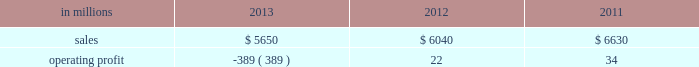Input costs for board and resin are expected to be flat and operating costs are expected to decrease .
European consumer packaging net sales in 2013 were $ 380 million compared with $ 380 million in 2012 and $ 375 million in 2011 .
Operating profits in 2013 were $ 100 million compared with $ 99 million in 2012 and $ 93 million in 2011 .
Sales volumes in 2013 decreased from 2012 in both the european and russian markets .
Average sales price realizations were significantly higher in the russian market , but were lower in europe .
Input costs were flat year-over-year .
Planned maintenance downtime costs were higher in 2013 than in 2012 .
Looking forward to the first quarter of 2014 , sales volumes compared with the fourth quarter of 2013 are expected to be about flat .
Average sales price realizations are expected to be higher in both russia and europe .
Input costs are expected to increase for wood and energy , but decrease for purchased pulp .
There are no maintenance outages scheduled for the first quarter , however the kwidzyn mill will have additional costs associated with the rebuild of a coated board machine .
Asian consumer packaging net sales were $ 1.1 billion in 2013 compared with $ 830 million in 2012 and $ 855 million in 2011 .
Operating profits in 2013 were a loss of $ 2 million compared with gains of $ 4 million in 2012 and $ 35 million in 2011 .
Sales volumes increased in 2013 compared with 2012 , reflecting the ramp-up of a new coated paperboard machine installed in 2012 .
However , average sales price realizations were significantly lower , reflecting competitive pressure on sales prices which squeezed margins and created an unfavorable product mix .
Lower input costs were offset by higher freight costs .
In 2012 , start-up costs for the new coated paperboard machine adversely impacted operating profits .
In the first quarter of 2014 , sales volumes are expected to increase slightly .
Average sales price realizations are expected to be flat reflecting continuing competitive pressures .
Input costs are expected be higher for pulp , energy and chemicals .
The business will drive margin improvement through operational excellence and better distribution xpedx , our distribution business , is one of north america 2019s leading business-to-business distributors to manufacturers , facility managers and printers , providing customized solutions that are designed to improve efficiency , reduce costs and deliver results .
Customer demand is generally sensitive to changes in economic conditions and consumer behavior , along with segment specific activity including corporate advertising and promotional spending , government spending and domestic manufacturing activity .
Distribution 2019s margins are relatively stable across an economic cycle .
Providing customers with the best choice for value in both products and supply chain services is a key competitive factor .
Additionally , efficient customer service , cost-effective logistics and focused working capital management are key factors in this segment 2019s profitability .
Distribution .
Distribution 2019s 2013 annual sales decreased 6% ( 6 % ) from 2012 , and decreased 15% ( 15 % ) from 2011 .
Operating profits in 2013 were a loss of $ 389 million ( a gain of $ 43 million excluding goodwill impairment charges and reorganization costs ) compared with $ 22 million ( $ 71 million excluding reorganization costs ) in 2012 and $ 34 million ( $ 86 million excluding reorganization costs ) in annual sales of printing papers and graphic arts supplies and equipment totaled $ 3.2 billion in 2013 compared with $ 3.5 billion in 2012 and $ 4.0 billion in 2011 reflecting declining demand and the discontinuation of a distribution agreement with a large manufacturer of graphic supplies .
Trade margins as a percent of sales for printing papers were down from both 2012 and 2011 .
Revenue from packaging products was flat at $ 1.6 billion in 2013 , 2012 and 2011 despite the significant decline of a large high-tech customer's business .
Packaging margins remained flat to the 2012 level , and up from 2011 .
Facility supplies annual revenue was $ 845 million in 2013 , down from $ 944 million in 2012 and $ 981 million in 2011 .
Operating profits in 2013 included a goodwill impairment charge of $ 400 million and reorganization costs for severance , professional services and asset write-downs of $ 32 million .
Operating profits in 2012 and 2011 included reorganization costs of $ 49 million and $ 52 million , respectively .
Looking ahead to the 2014 first quarter , operating profits will be seasonally lower , but will continue to reflect the benefits of strategic and other cost reduction initiatives. .
What was the distribution profit margin in 2011? 
Computations: (34 / 6630)
Answer: 0.00513. 